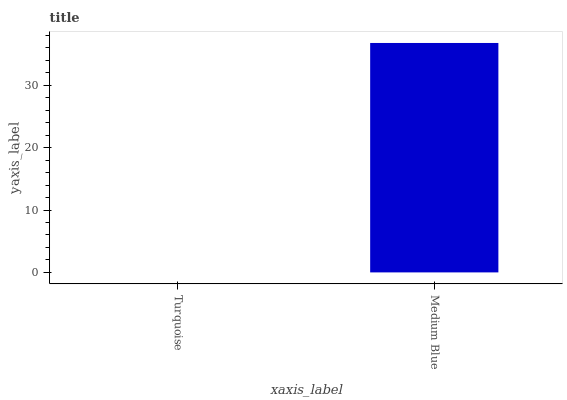Is Turquoise the minimum?
Answer yes or no. Yes. Is Medium Blue the maximum?
Answer yes or no. Yes. Is Medium Blue the minimum?
Answer yes or no. No. Is Medium Blue greater than Turquoise?
Answer yes or no. Yes. Is Turquoise less than Medium Blue?
Answer yes or no. Yes. Is Turquoise greater than Medium Blue?
Answer yes or no. No. Is Medium Blue less than Turquoise?
Answer yes or no. No. Is Medium Blue the high median?
Answer yes or no. Yes. Is Turquoise the low median?
Answer yes or no. Yes. Is Turquoise the high median?
Answer yes or no. No. Is Medium Blue the low median?
Answer yes or no. No. 